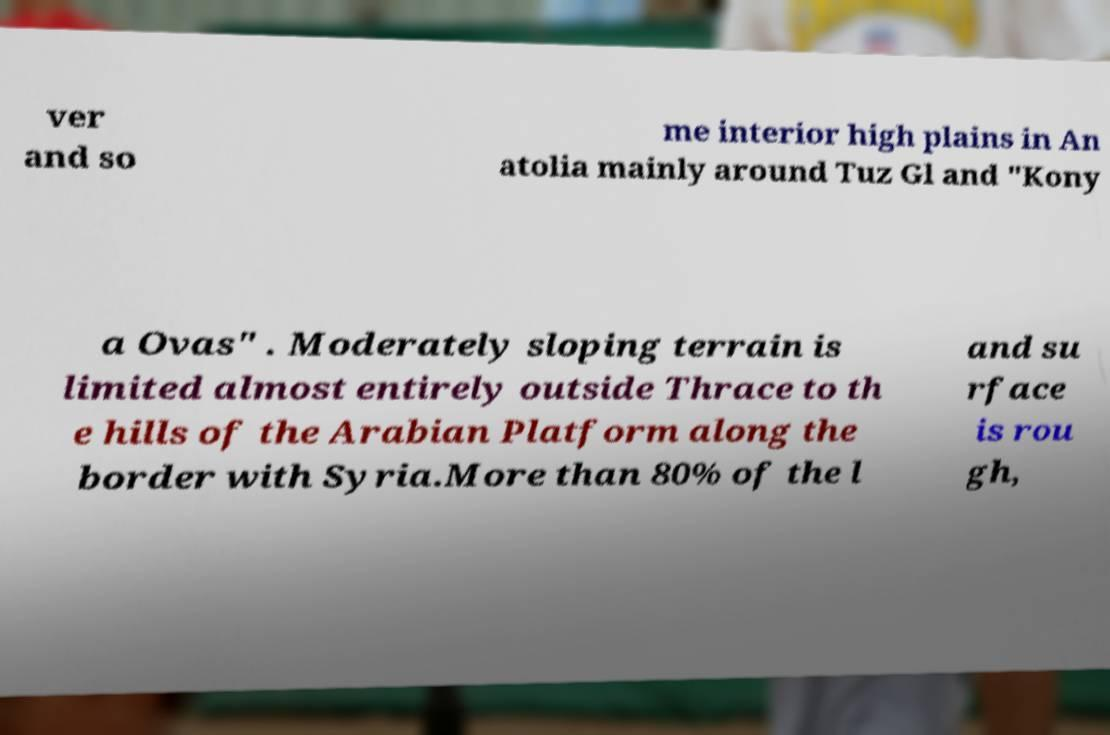Could you assist in decoding the text presented in this image and type it out clearly? ver and so me interior high plains in An atolia mainly around Tuz Gl and "Kony a Ovas" . Moderately sloping terrain is limited almost entirely outside Thrace to th e hills of the Arabian Platform along the border with Syria.More than 80% of the l and su rface is rou gh, 